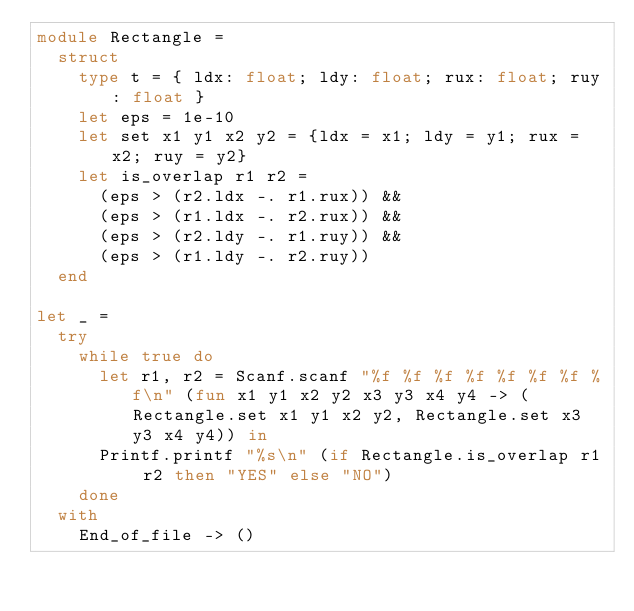<code> <loc_0><loc_0><loc_500><loc_500><_OCaml_>module Rectangle =
  struct
    type t = { ldx: float; ldy: float; rux: float; ruy: float }
    let eps = 1e-10
    let set x1 y1 x2 y2 = {ldx = x1; ldy = y1; rux = x2; ruy = y2}
    let is_overlap r1 r2 =
      (eps > (r2.ldx -. r1.rux)) &&
      (eps > (r1.ldx -. r2.rux)) &&
      (eps > (r2.ldy -. r1.ruy)) &&
      (eps > (r1.ldy -. r2.ruy))
  end

let _ =
  try
    while true do
      let r1, r2 = Scanf.scanf "%f %f %f %f %f %f %f %f\n" (fun x1 y1 x2 y2 x3 y3 x4 y4 -> (Rectangle.set x1 y1 x2 y2, Rectangle.set x3 y3 x4 y4)) in
      Printf.printf "%s\n" (if Rectangle.is_overlap r1 r2 then "YES" else "NO")
    done
  with
    End_of_file -> ()</code> 